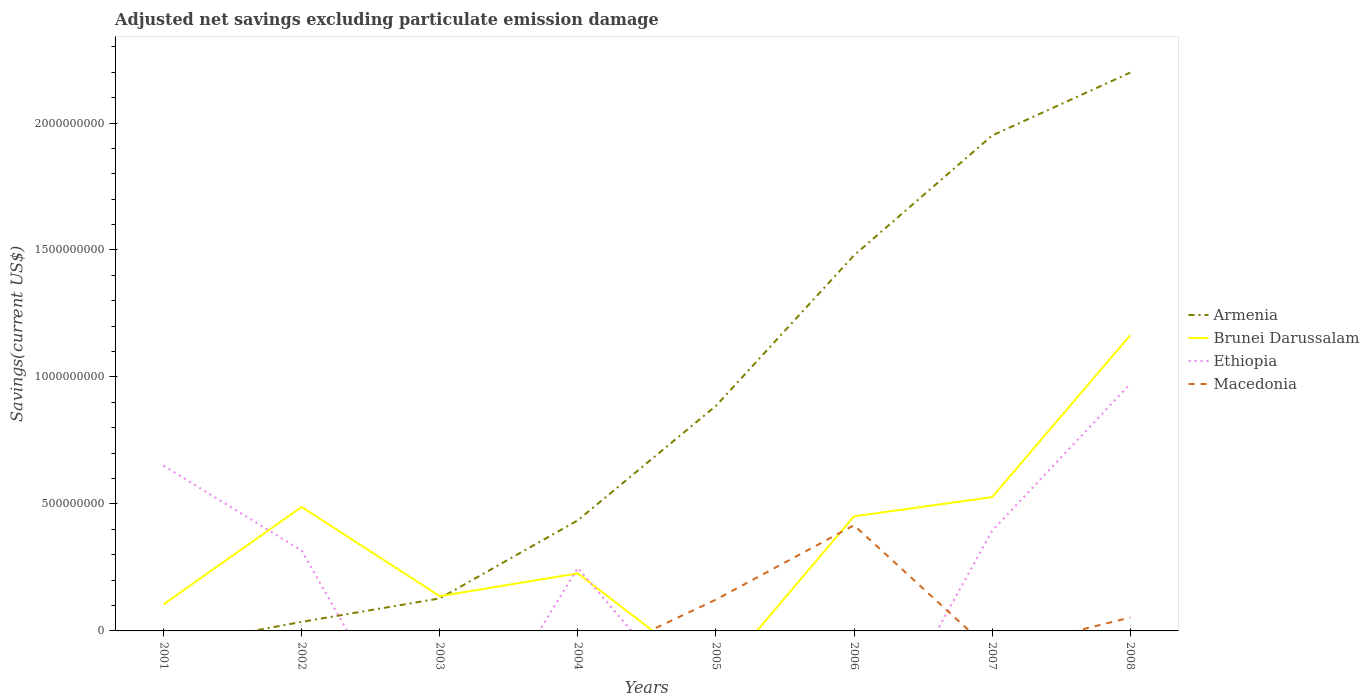Does the line corresponding to Ethiopia intersect with the line corresponding to Macedonia?
Provide a short and direct response. Yes. What is the total adjusted net savings in Brunei Darussalam in the graph?
Give a very brief answer. -3.00e+08. What is the difference between the highest and the second highest adjusted net savings in Brunei Darussalam?
Your answer should be compact. 1.16e+09. Is the adjusted net savings in Ethiopia strictly greater than the adjusted net savings in Macedonia over the years?
Your answer should be very brief. No. How many lines are there?
Offer a terse response. 4. Are the values on the major ticks of Y-axis written in scientific E-notation?
Keep it short and to the point. No. Does the graph contain grids?
Your response must be concise. No. Where does the legend appear in the graph?
Your response must be concise. Center right. How many legend labels are there?
Provide a short and direct response. 4. How are the legend labels stacked?
Ensure brevity in your answer.  Vertical. What is the title of the graph?
Your answer should be very brief. Adjusted net savings excluding particulate emission damage. What is the label or title of the X-axis?
Your answer should be very brief. Years. What is the label or title of the Y-axis?
Your answer should be very brief. Savings(current US$). What is the Savings(current US$) in Brunei Darussalam in 2001?
Offer a very short reply. 1.05e+08. What is the Savings(current US$) of Ethiopia in 2001?
Your response must be concise. 6.51e+08. What is the Savings(current US$) of Armenia in 2002?
Your answer should be compact. 3.57e+07. What is the Savings(current US$) of Brunei Darussalam in 2002?
Ensure brevity in your answer.  4.88e+08. What is the Savings(current US$) of Ethiopia in 2002?
Ensure brevity in your answer.  3.16e+08. What is the Savings(current US$) of Macedonia in 2002?
Provide a short and direct response. 0. What is the Savings(current US$) of Armenia in 2003?
Give a very brief answer. 1.28e+08. What is the Savings(current US$) of Brunei Darussalam in 2003?
Provide a short and direct response. 1.37e+08. What is the Savings(current US$) of Armenia in 2004?
Make the answer very short. 4.36e+08. What is the Savings(current US$) in Brunei Darussalam in 2004?
Offer a terse response. 2.27e+08. What is the Savings(current US$) in Ethiopia in 2004?
Offer a terse response. 2.48e+08. What is the Savings(current US$) in Armenia in 2005?
Provide a succinct answer. 8.86e+08. What is the Savings(current US$) in Ethiopia in 2005?
Make the answer very short. 0. What is the Savings(current US$) in Macedonia in 2005?
Provide a short and direct response. 1.23e+08. What is the Savings(current US$) of Armenia in 2006?
Your response must be concise. 1.48e+09. What is the Savings(current US$) in Brunei Darussalam in 2006?
Offer a terse response. 4.51e+08. What is the Savings(current US$) of Macedonia in 2006?
Make the answer very short. 4.16e+08. What is the Savings(current US$) of Armenia in 2007?
Offer a very short reply. 1.95e+09. What is the Savings(current US$) in Brunei Darussalam in 2007?
Give a very brief answer. 5.27e+08. What is the Savings(current US$) in Ethiopia in 2007?
Offer a very short reply. 3.94e+08. What is the Savings(current US$) in Macedonia in 2007?
Ensure brevity in your answer.  0. What is the Savings(current US$) in Armenia in 2008?
Your answer should be compact. 2.20e+09. What is the Savings(current US$) of Brunei Darussalam in 2008?
Provide a succinct answer. 1.16e+09. What is the Savings(current US$) of Ethiopia in 2008?
Make the answer very short. 9.73e+08. What is the Savings(current US$) in Macedonia in 2008?
Keep it short and to the point. 5.27e+07. Across all years, what is the maximum Savings(current US$) of Armenia?
Your answer should be very brief. 2.20e+09. Across all years, what is the maximum Savings(current US$) of Brunei Darussalam?
Your answer should be very brief. 1.16e+09. Across all years, what is the maximum Savings(current US$) in Ethiopia?
Offer a very short reply. 9.73e+08. Across all years, what is the maximum Savings(current US$) of Macedonia?
Offer a terse response. 4.16e+08. Across all years, what is the minimum Savings(current US$) of Armenia?
Keep it short and to the point. 0. Across all years, what is the minimum Savings(current US$) in Brunei Darussalam?
Ensure brevity in your answer.  0. Across all years, what is the minimum Savings(current US$) of Macedonia?
Provide a succinct answer. 0. What is the total Savings(current US$) in Armenia in the graph?
Your answer should be very brief. 7.11e+09. What is the total Savings(current US$) of Brunei Darussalam in the graph?
Ensure brevity in your answer.  3.10e+09. What is the total Savings(current US$) in Ethiopia in the graph?
Provide a succinct answer. 2.58e+09. What is the total Savings(current US$) of Macedonia in the graph?
Ensure brevity in your answer.  5.92e+08. What is the difference between the Savings(current US$) in Brunei Darussalam in 2001 and that in 2002?
Give a very brief answer. -3.84e+08. What is the difference between the Savings(current US$) of Ethiopia in 2001 and that in 2002?
Give a very brief answer. 3.34e+08. What is the difference between the Savings(current US$) of Brunei Darussalam in 2001 and that in 2003?
Provide a short and direct response. -3.24e+07. What is the difference between the Savings(current US$) of Brunei Darussalam in 2001 and that in 2004?
Your answer should be compact. -1.22e+08. What is the difference between the Savings(current US$) in Ethiopia in 2001 and that in 2004?
Your answer should be very brief. 4.03e+08. What is the difference between the Savings(current US$) in Brunei Darussalam in 2001 and that in 2006?
Your answer should be very brief. -3.47e+08. What is the difference between the Savings(current US$) in Brunei Darussalam in 2001 and that in 2007?
Ensure brevity in your answer.  -4.22e+08. What is the difference between the Savings(current US$) of Ethiopia in 2001 and that in 2007?
Offer a terse response. 2.56e+08. What is the difference between the Savings(current US$) of Brunei Darussalam in 2001 and that in 2008?
Your response must be concise. -1.06e+09. What is the difference between the Savings(current US$) in Ethiopia in 2001 and that in 2008?
Your response must be concise. -3.22e+08. What is the difference between the Savings(current US$) of Armenia in 2002 and that in 2003?
Make the answer very short. -9.23e+07. What is the difference between the Savings(current US$) of Brunei Darussalam in 2002 and that in 2003?
Make the answer very short. 3.51e+08. What is the difference between the Savings(current US$) of Armenia in 2002 and that in 2004?
Your answer should be very brief. -4.00e+08. What is the difference between the Savings(current US$) in Brunei Darussalam in 2002 and that in 2004?
Your answer should be very brief. 2.62e+08. What is the difference between the Savings(current US$) in Ethiopia in 2002 and that in 2004?
Your answer should be compact. 6.85e+07. What is the difference between the Savings(current US$) of Armenia in 2002 and that in 2005?
Your answer should be compact. -8.50e+08. What is the difference between the Savings(current US$) of Armenia in 2002 and that in 2006?
Offer a very short reply. -1.44e+09. What is the difference between the Savings(current US$) of Brunei Darussalam in 2002 and that in 2006?
Ensure brevity in your answer.  3.69e+07. What is the difference between the Savings(current US$) of Armenia in 2002 and that in 2007?
Your answer should be compact. -1.92e+09. What is the difference between the Savings(current US$) in Brunei Darussalam in 2002 and that in 2007?
Ensure brevity in your answer.  -3.85e+07. What is the difference between the Savings(current US$) of Ethiopia in 2002 and that in 2007?
Give a very brief answer. -7.81e+07. What is the difference between the Savings(current US$) in Armenia in 2002 and that in 2008?
Offer a very short reply. -2.16e+09. What is the difference between the Savings(current US$) in Brunei Darussalam in 2002 and that in 2008?
Your answer should be compact. -6.76e+08. What is the difference between the Savings(current US$) of Ethiopia in 2002 and that in 2008?
Make the answer very short. -6.56e+08. What is the difference between the Savings(current US$) of Armenia in 2003 and that in 2004?
Provide a short and direct response. -3.08e+08. What is the difference between the Savings(current US$) in Brunei Darussalam in 2003 and that in 2004?
Make the answer very short. -8.97e+07. What is the difference between the Savings(current US$) of Armenia in 2003 and that in 2005?
Make the answer very short. -7.58e+08. What is the difference between the Savings(current US$) in Armenia in 2003 and that in 2006?
Offer a very short reply. -1.35e+09. What is the difference between the Savings(current US$) of Brunei Darussalam in 2003 and that in 2006?
Your answer should be compact. -3.14e+08. What is the difference between the Savings(current US$) in Armenia in 2003 and that in 2007?
Provide a succinct answer. -1.82e+09. What is the difference between the Savings(current US$) of Brunei Darussalam in 2003 and that in 2007?
Your answer should be compact. -3.90e+08. What is the difference between the Savings(current US$) in Armenia in 2003 and that in 2008?
Give a very brief answer. -2.07e+09. What is the difference between the Savings(current US$) in Brunei Darussalam in 2003 and that in 2008?
Give a very brief answer. -1.03e+09. What is the difference between the Savings(current US$) of Armenia in 2004 and that in 2005?
Give a very brief answer. -4.50e+08. What is the difference between the Savings(current US$) in Armenia in 2004 and that in 2006?
Your answer should be compact. -1.04e+09. What is the difference between the Savings(current US$) in Brunei Darussalam in 2004 and that in 2006?
Offer a very short reply. -2.25e+08. What is the difference between the Savings(current US$) in Armenia in 2004 and that in 2007?
Offer a very short reply. -1.52e+09. What is the difference between the Savings(current US$) in Brunei Darussalam in 2004 and that in 2007?
Provide a short and direct response. -3.00e+08. What is the difference between the Savings(current US$) of Ethiopia in 2004 and that in 2007?
Keep it short and to the point. -1.47e+08. What is the difference between the Savings(current US$) in Armenia in 2004 and that in 2008?
Keep it short and to the point. -1.76e+09. What is the difference between the Savings(current US$) of Brunei Darussalam in 2004 and that in 2008?
Your answer should be compact. -9.38e+08. What is the difference between the Savings(current US$) of Ethiopia in 2004 and that in 2008?
Ensure brevity in your answer.  -7.25e+08. What is the difference between the Savings(current US$) in Armenia in 2005 and that in 2006?
Ensure brevity in your answer.  -5.93e+08. What is the difference between the Savings(current US$) in Macedonia in 2005 and that in 2006?
Your answer should be very brief. -2.93e+08. What is the difference between the Savings(current US$) of Armenia in 2005 and that in 2007?
Provide a short and direct response. -1.06e+09. What is the difference between the Savings(current US$) in Armenia in 2005 and that in 2008?
Your answer should be compact. -1.31e+09. What is the difference between the Savings(current US$) of Macedonia in 2005 and that in 2008?
Your answer should be compact. 7.05e+07. What is the difference between the Savings(current US$) in Armenia in 2006 and that in 2007?
Your answer should be very brief. -4.72e+08. What is the difference between the Savings(current US$) of Brunei Darussalam in 2006 and that in 2007?
Ensure brevity in your answer.  -7.55e+07. What is the difference between the Savings(current US$) in Armenia in 2006 and that in 2008?
Your answer should be very brief. -7.20e+08. What is the difference between the Savings(current US$) in Brunei Darussalam in 2006 and that in 2008?
Your response must be concise. -7.13e+08. What is the difference between the Savings(current US$) of Macedonia in 2006 and that in 2008?
Ensure brevity in your answer.  3.63e+08. What is the difference between the Savings(current US$) of Armenia in 2007 and that in 2008?
Your answer should be very brief. -2.48e+08. What is the difference between the Savings(current US$) in Brunei Darussalam in 2007 and that in 2008?
Make the answer very short. -6.38e+08. What is the difference between the Savings(current US$) in Ethiopia in 2007 and that in 2008?
Keep it short and to the point. -5.78e+08. What is the difference between the Savings(current US$) in Brunei Darussalam in 2001 and the Savings(current US$) in Ethiopia in 2002?
Give a very brief answer. -2.12e+08. What is the difference between the Savings(current US$) of Brunei Darussalam in 2001 and the Savings(current US$) of Ethiopia in 2004?
Give a very brief answer. -1.43e+08. What is the difference between the Savings(current US$) of Brunei Darussalam in 2001 and the Savings(current US$) of Macedonia in 2005?
Provide a succinct answer. -1.87e+07. What is the difference between the Savings(current US$) in Ethiopia in 2001 and the Savings(current US$) in Macedonia in 2005?
Provide a short and direct response. 5.27e+08. What is the difference between the Savings(current US$) in Brunei Darussalam in 2001 and the Savings(current US$) in Macedonia in 2006?
Make the answer very short. -3.12e+08. What is the difference between the Savings(current US$) of Ethiopia in 2001 and the Savings(current US$) of Macedonia in 2006?
Offer a very short reply. 2.35e+08. What is the difference between the Savings(current US$) of Brunei Darussalam in 2001 and the Savings(current US$) of Ethiopia in 2007?
Offer a terse response. -2.90e+08. What is the difference between the Savings(current US$) of Brunei Darussalam in 2001 and the Savings(current US$) of Ethiopia in 2008?
Your answer should be very brief. -8.68e+08. What is the difference between the Savings(current US$) of Brunei Darussalam in 2001 and the Savings(current US$) of Macedonia in 2008?
Ensure brevity in your answer.  5.18e+07. What is the difference between the Savings(current US$) of Ethiopia in 2001 and the Savings(current US$) of Macedonia in 2008?
Provide a succinct answer. 5.98e+08. What is the difference between the Savings(current US$) in Armenia in 2002 and the Savings(current US$) in Brunei Darussalam in 2003?
Your answer should be very brief. -1.01e+08. What is the difference between the Savings(current US$) of Armenia in 2002 and the Savings(current US$) of Brunei Darussalam in 2004?
Provide a short and direct response. -1.91e+08. What is the difference between the Savings(current US$) in Armenia in 2002 and the Savings(current US$) in Ethiopia in 2004?
Give a very brief answer. -2.12e+08. What is the difference between the Savings(current US$) of Brunei Darussalam in 2002 and the Savings(current US$) of Ethiopia in 2004?
Offer a very short reply. 2.40e+08. What is the difference between the Savings(current US$) in Armenia in 2002 and the Savings(current US$) in Macedonia in 2005?
Your answer should be compact. -8.76e+07. What is the difference between the Savings(current US$) in Brunei Darussalam in 2002 and the Savings(current US$) in Macedonia in 2005?
Offer a terse response. 3.65e+08. What is the difference between the Savings(current US$) of Ethiopia in 2002 and the Savings(current US$) of Macedonia in 2005?
Offer a terse response. 1.93e+08. What is the difference between the Savings(current US$) in Armenia in 2002 and the Savings(current US$) in Brunei Darussalam in 2006?
Your answer should be very brief. -4.16e+08. What is the difference between the Savings(current US$) of Armenia in 2002 and the Savings(current US$) of Macedonia in 2006?
Your answer should be very brief. -3.80e+08. What is the difference between the Savings(current US$) of Brunei Darussalam in 2002 and the Savings(current US$) of Macedonia in 2006?
Offer a terse response. 7.22e+07. What is the difference between the Savings(current US$) in Ethiopia in 2002 and the Savings(current US$) in Macedonia in 2006?
Provide a short and direct response. -9.97e+07. What is the difference between the Savings(current US$) of Armenia in 2002 and the Savings(current US$) of Brunei Darussalam in 2007?
Give a very brief answer. -4.91e+08. What is the difference between the Savings(current US$) of Armenia in 2002 and the Savings(current US$) of Ethiopia in 2007?
Provide a short and direct response. -3.59e+08. What is the difference between the Savings(current US$) in Brunei Darussalam in 2002 and the Savings(current US$) in Ethiopia in 2007?
Offer a terse response. 9.38e+07. What is the difference between the Savings(current US$) in Armenia in 2002 and the Savings(current US$) in Brunei Darussalam in 2008?
Ensure brevity in your answer.  -1.13e+09. What is the difference between the Savings(current US$) in Armenia in 2002 and the Savings(current US$) in Ethiopia in 2008?
Your answer should be very brief. -9.37e+08. What is the difference between the Savings(current US$) in Armenia in 2002 and the Savings(current US$) in Macedonia in 2008?
Give a very brief answer. -1.71e+07. What is the difference between the Savings(current US$) of Brunei Darussalam in 2002 and the Savings(current US$) of Ethiopia in 2008?
Provide a succinct answer. -4.84e+08. What is the difference between the Savings(current US$) in Brunei Darussalam in 2002 and the Savings(current US$) in Macedonia in 2008?
Provide a short and direct response. 4.36e+08. What is the difference between the Savings(current US$) of Ethiopia in 2002 and the Savings(current US$) of Macedonia in 2008?
Your answer should be very brief. 2.64e+08. What is the difference between the Savings(current US$) in Armenia in 2003 and the Savings(current US$) in Brunei Darussalam in 2004?
Keep it short and to the point. -9.87e+07. What is the difference between the Savings(current US$) of Armenia in 2003 and the Savings(current US$) of Ethiopia in 2004?
Offer a very short reply. -1.20e+08. What is the difference between the Savings(current US$) in Brunei Darussalam in 2003 and the Savings(current US$) in Ethiopia in 2004?
Your answer should be very brief. -1.11e+08. What is the difference between the Savings(current US$) in Armenia in 2003 and the Savings(current US$) in Macedonia in 2005?
Offer a very short reply. 4.75e+06. What is the difference between the Savings(current US$) in Brunei Darussalam in 2003 and the Savings(current US$) in Macedonia in 2005?
Make the answer very short. 1.37e+07. What is the difference between the Savings(current US$) in Armenia in 2003 and the Savings(current US$) in Brunei Darussalam in 2006?
Your answer should be very brief. -3.23e+08. What is the difference between the Savings(current US$) of Armenia in 2003 and the Savings(current US$) of Macedonia in 2006?
Give a very brief answer. -2.88e+08. What is the difference between the Savings(current US$) of Brunei Darussalam in 2003 and the Savings(current US$) of Macedonia in 2006?
Make the answer very short. -2.79e+08. What is the difference between the Savings(current US$) in Armenia in 2003 and the Savings(current US$) in Brunei Darussalam in 2007?
Make the answer very short. -3.99e+08. What is the difference between the Savings(current US$) in Armenia in 2003 and the Savings(current US$) in Ethiopia in 2007?
Your response must be concise. -2.67e+08. What is the difference between the Savings(current US$) of Brunei Darussalam in 2003 and the Savings(current US$) of Ethiopia in 2007?
Provide a short and direct response. -2.58e+08. What is the difference between the Savings(current US$) of Armenia in 2003 and the Savings(current US$) of Brunei Darussalam in 2008?
Provide a succinct answer. -1.04e+09. What is the difference between the Savings(current US$) in Armenia in 2003 and the Savings(current US$) in Ethiopia in 2008?
Your answer should be very brief. -8.45e+08. What is the difference between the Savings(current US$) of Armenia in 2003 and the Savings(current US$) of Macedonia in 2008?
Give a very brief answer. 7.52e+07. What is the difference between the Savings(current US$) in Brunei Darussalam in 2003 and the Savings(current US$) in Ethiopia in 2008?
Ensure brevity in your answer.  -8.36e+08. What is the difference between the Savings(current US$) in Brunei Darussalam in 2003 and the Savings(current US$) in Macedonia in 2008?
Make the answer very short. 8.42e+07. What is the difference between the Savings(current US$) in Armenia in 2004 and the Savings(current US$) in Macedonia in 2005?
Offer a very short reply. 3.12e+08. What is the difference between the Savings(current US$) in Brunei Darussalam in 2004 and the Savings(current US$) in Macedonia in 2005?
Offer a very short reply. 1.03e+08. What is the difference between the Savings(current US$) in Ethiopia in 2004 and the Savings(current US$) in Macedonia in 2005?
Provide a short and direct response. 1.25e+08. What is the difference between the Savings(current US$) in Armenia in 2004 and the Savings(current US$) in Brunei Darussalam in 2006?
Give a very brief answer. -1.58e+07. What is the difference between the Savings(current US$) in Armenia in 2004 and the Savings(current US$) in Macedonia in 2006?
Offer a terse response. 1.95e+07. What is the difference between the Savings(current US$) in Brunei Darussalam in 2004 and the Savings(current US$) in Macedonia in 2006?
Keep it short and to the point. -1.89e+08. What is the difference between the Savings(current US$) in Ethiopia in 2004 and the Savings(current US$) in Macedonia in 2006?
Provide a short and direct response. -1.68e+08. What is the difference between the Savings(current US$) in Armenia in 2004 and the Savings(current US$) in Brunei Darussalam in 2007?
Give a very brief answer. -9.12e+07. What is the difference between the Savings(current US$) of Armenia in 2004 and the Savings(current US$) of Ethiopia in 2007?
Keep it short and to the point. 4.11e+07. What is the difference between the Savings(current US$) in Brunei Darussalam in 2004 and the Savings(current US$) in Ethiopia in 2007?
Offer a terse response. -1.68e+08. What is the difference between the Savings(current US$) of Armenia in 2004 and the Savings(current US$) of Brunei Darussalam in 2008?
Provide a succinct answer. -7.29e+08. What is the difference between the Savings(current US$) of Armenia in 2004 and the Savings(current US$) of Ethiopia in 2008?
Your response must be concise. -5.37e+08. What is the difference between the Savings(current US$) in Armenia in 2004 and the Savings(current US$) in Macedonia in 2008?
Offer a very short reply. 3.83e+08. What is the difference between the Savings(current US$) in Brunei Darussalam in 2004 and the Savings(current US$) in Ethiopia in 2008?
Your response must be concise. -7.46e+08. What is the difference between the Savings(current US$) in Brunei Darussalam in 2004 and the Savings(current US$) in Macedonia in 2008?
Offer a very short reply. 1.74e+08. What is the difference between the Savings(current US$) of Ethiopia in 2004 and the Savings(current US$) of Macedonia in 2008?
Your response must be concise. 1.95e+08. What is the difference between the Savings(current US$) in Armenia in 2005 and the Savings(current US$) in Brunei Darussalam in 2006?
Your response must be concise. 4.35e+08. What is the difference between the Savings(current US$) of Armenia in 2005 and the Savings(current US$) of Macedonia in 2006?
Offer a terse response. 4.70e+08. What is the difference between the Savings(current US$) in Armenia in 2005 and the Savings(current US$) in Brunei Darussalam in 2007?
Your response must be concise. 3.59e+08. What is the difference between the Savings(current US$) of Armenia in 2005 and the Savings(current US$) of Ethiopia in 2007?
Your answer should be compact. 4.92e+08. What is the difference between the Savings(current US$) in Armenia in 2005 and the Savings(current US$) in Brunei Darussalam in 2008?
Your answer should be compact. -2.78e+08. What is the difference between the Savings(current US$) in Armenia in 2005 and the Savings(current US$) in Ethiopia in 2008?
Keep it short and to the point. -8.66e+07. What is the difference between the Savings(current US$) of Armenia in 2005 and the Savings(current US$) of Macedonia in 2008?
Your answer should be compact. 8.33e+08. What is the difference between the Savings(current US$) in Armenia in 2006 and the Savings(current US$) in Brunei Darussalam in 2007?
Your response must be concise. 9.52e+08. What is the difference between the Savings(current US$) in Armenia in 2006 and the Savings(current US$) in Ethiopia in 2007?
Provide a succinct answer. 1.08e+09. What is the difference between the Savings(current US$) in Brunei Darussalam in 2006 and the Savings(current US$) in Ethiopia in 2007?
Your answer should be compact. 5.69e+07. What is the difference between the Savings(current US$) of Armenia in 2006 and the Savings(current US$) of Brunei Darussalam in 2008?
Keep it short and to the point. 3.15e+08. What is the difference between the Savings(current US$) in Armenia in 2006 and the Savings(current US$) in Ethiopia in 2008?
Offer a terse response. 5.06e+08. What is the difference between the Savings(current US$) of Armenia in 2006 and the Savings(current US$) of Macedonia in 2008?
Your response must be concise. 1.43e+09. What is the difference between the Savings(current US$) in Brunei Darussalam in 2006 and the Savings(current US$) in Ethiopia in 2008?
Your answer should be very brief. -5.21e+08. What is the difference between the Savings(current US$) of Brunei Darussalam in 2006 and the Savings(current US$) of Macedonia in 2008?
Ensure brevity in your answer.  3.99e+08. What is the difference between the Savings(current US$) in Armenia in 2007 and the Savings(current US$) in Brunei Darussalam in 2008?
Your answer should be compact. 7.86e+08. What is the difference between the Savings(current US$) in Armenia in 2007 and the Savings(current US$) in Ethiopia in 2008?
Your response must be concise. 9.78e+08. What is the difference between the Savings(current US$) of Armenia in 2007 and the Savings(current US$) of Macedonia in 2008?
Provide a succinct answer. 1.90e+09. What is the difference between the Savings(current US$) in Brunei Darussalam in 2007 and the Savings(current US$) in Ethiopia in 2008?
Make the answer very short. -4.46e+08. What is the difference between the Savings(current US$) of Brunei Darussalam in 2007 and the Savings(current US$) of Macedonia in 2008?
Provide a short and direct response. 4.74e+08. What is the difference between the Savings(current US$) of Ethiopia in 2007 and the Savings(current US$) of Macedonia in 2008?
Your answer should be very brief. 3.42e+08. What is the average Savings(current US$) of Armenia per year?
Ensure brevity in your answer.  8.89e+08. What is the average Savings(current US$) in Brunei Darussalam per year?
Ensure brevity in your answer.  3.87e+08. What is the average Savings(current US$) of Ethiopia per year?
Make the answer very short. 3.23e+08. What is the average Savings(current US$) of Macedonia per year?
Offer a terse response. 7.40e+07. In the year 2001, what is the difference between the Savings(current US$) in Brunei Darussalam and Savings(current US$) in Ethiopia?
Make the answer very short. -5.46e+08. In the year 2002, what is the difference between the Savings(current US$) in Armenia and Savings(current US$) in Brunei Darussalam?
Your response must be concise. -4.53e+08. In the year 2002, what is the difference between the Savings(current US$) of Armenia and Savings(current US$) of Ethiopia?
Provide a short and direct response. -2.81e+08. In the year 2002, what is the difference between the Savings(current US$) of Brunei Darussalam and Savings(current US$) of Ethiopia?
Provide a succinct answer. 1.72e+08. In the year 2003, what is the difference between the Savings(current US$) of Armenia and Savings(current US$) of Brunei Darussalam?
Offer a terse response. -8.96e+06. In the year 2004, what is the difference between the Savings(current US$) in Armenia and Savings(current US$) in Brunei Darussalam?
Make the answer very short. 2.09e+08. In the year 2004, what is the difference between the Savings(current US$) of Armenia and Savings(current US$) of Ethiopia?
Provide a succinct answer. 1.88e+08. In the year 2004, what is the difference between the Savings(current US$) of Brunei Darussalam and Savings(current US$) of Ethiopia?
Your answer should be very brief. -2.12e+07. In the year 2005, what is the difference between the Savings(current US$) of Armenia and Savings(current US$) of Macedonia?
Make the answer very short. 7.63e+08. In the year 2006, what is the difference between the Savings(current US$) of Armenia and Savings(current US$) of Brunei Darussalam?
Your answer should be compact. 1.03e+09. In the year 2006, what is the difference between the Savings(current US$) of Armenia and Savings(current US$) of Macedonia?
Ensure brevity in your answer.  1.06e+09. In the year 2006, what is the difference between the Savings(current US$) in Brunei Darussalam and Savings(current US$) in Macedonia?
Give a very brief answer. 3.53e+07. In the year 2007, what is the difference between the Savings(current US$) of Armenia and Savings(current US$) of Brunei Darussalam?
Your answer should be very brief. 1.42e+09. In the year 2007, what is the difference between the Savings(current US$) in Armenia and Savings(current US$) in Ethiopia?
Give a very brief answer. 1.56e+09. In the year 2007, what is the difference between the Savings(current US$) of Brunei Darussalam and Savings(current US$) of Ethiopia?
Keep it short and to the point. 1.32e+08. In the year 2008, what is the difference between the Savings(current US$) of Armenia and Savings(current US$) of Brunei Darussalam?
Ensure brevity in your answer.  1.03e+09. In the year 2008, what is the difference between the Savings(current US$) of Armenia and Savings(current US$) of Ethiopia?
Ensure brevity in your answer.  1.23e+09. In the year 2008, what is the difference between the Savings(current US$) in Armenia and Savings(current US$) in Macedonia?
Ensure brevity in your answer.  2.15e+09. In the year 2008, what is the difference between the Savings(current US$) in Brunei Darussalam and Savings(current US$) in Ethiopia?
Your answer should be compact. 1.92e+08. In the year 2008, what is the difference between the Savings(current US$) of Brunei Darussalam and Savings(current US$) of Macedonia?
Provide a succinct answer. 1.11e+09. In the year 2008, what is the difference between the Savings(current US$) in Ethiopia and Savings(current US$) in Macedonia?
Offer a very short reply. 9.20e+08. What is the ratio of the Savings(current US$) in Brunei Darussalam in 2001 to that in 2002?
Offer a very short reply. 0.21. What is the ratio of the Savings(current US$) of Ethiopia in 2001 to that in 2002?
Your answer should be very brief. 2.06. What is the ratio of the Savings(current US$) of Brunei Darussalam in 2001 to that in 2003?
Provide a short and direct response. 0.76. What is the ratio of the Savings(current US$) of Brunei Darussalam in 2001 to that in 2004?
Provide a short and direct response. 0.46. What is the ratio of the Savings(current US$) in Ethiopia in 2001 to that in 2004?
Offer a very short reply. 2.62. What is the ratio of the Savings(current US$) of Brunei Darussalam in 2001 to that in 2006?
Give a very brief answer. 0.23. What is the ratio of the Savings(current US$) in Brunei Darussalam in 2001 to that in 2007?
Offer a very short reply. 0.2. What is the ratio of the Savings(current US$) of Ethiopia in 2001 to that in 2007?
Provide a succinct answer. 1.65. What is the ratio of the Savings(current US$) of Brunei Darussalam in 2001 to that in 2008?
Provide a short and direct response. 0.09. What is the ratio of the Savings(current US$) in Ethiopia in 2001 to that in 2008?
Your answer should be compact. 0.67. What is the ratio of the Savings(current US$) in Armenia in 2002 to that in 2003?
Offer a very short reply. 0.28. What is the ratio of the Savings(current US$) in Brunei Darussalam in 2002 to that in 2003?
Give a very brief answer. 3.57. What is the ratio of the Savings(current US$) of Armenia in 2002 to that in 2004?
Your answer should be compact. 0.08. What is the ratio of the Savings(current US$) of Brunei Darussalam in 2002 to that in 2004?
Make the answer very short. 2.15. What is the ratio of the Savings(current US$) of Ethiopia in 2002 to that in 2004?
Your answer should be very brief. 1.28. What is the ratio of the Savings(current US$) of Armenia in 2002 to that in 2005?
Keep it short and to the point. 0.04. What is the ratio of the Savings(current US$) of Armenia in 2002 to that in 2006?
Your response must be concise. 0.02. What is the ratio of the Savings(current US$) in Brunei Darussalam in 2002 to that in 2006?
Offer a very short reply. 1.08. What is the ratio of the Savings(current US$) of Armenia in 2002 to that in 2007?
Offer a terse response. 0.02. What is the ratio of the Savings(current US$) of Brunei Darussalam in 2002 to that in 2007?
Ensure brevity in your answer.  0.93. What is the ratio of the Savings(current US$) of Ethiopia in 2002 to that in 2007?
Your answer should be compact. 0.8. What is the ratio of the Savings(current US$) of Armenia in 2002 to that in 2008?
Ensure brevity in your answer.  0.02. What is the ratio of the Savings(current US$) of Brunei Darussalam in 2002 to that in 2008?
Your answer should be compact. 0.42. What is the ratio of the Savings(current US$) of Ethiopia in 2002 to that in 2008?
Ensure brevity in your answer.  0.33. What is the ratio of the Savings(current US$) of Armenia in 2003 to that in 2004?
Your answer should be very brief. 0.29. What is the ratio of the Savings(current US$) in Brunei Darussalam in 2003 to that in 2004?
Offer a very short reply. 0.6. What is the ratio of the Savings(current US$) of Armenia in 2003 to that in 2005?
Offer a very short reply. 0.14. What is the ratio of the Savings(current US$) in Armenia in 2003 to that in 2006?
Ensure brevity in your answer.  0.09. What is the ratio of the Savings(current US$) in Brunei Darussalam in 2003 to that in 2006?
Offer a very short reply. 0.3. What is the ratio of the Savings(current US$) in Armenia in 2003 to that in 2007?
Your answer should be compact. 0.07. What is the ratio of the Savings(current US$) in Brunei Darussalam in 2003 to that in 2007?
Provide a short and direct response. 0.26. What is the ratio of the Savings(current US$) of Armenia in 2003 to that in 2008?
Offer a very short reply. 0.06. What is the ratio of the Savings(current US$) of Brunei Darussalam in 2003 to that in 2008?
Your response must be concise. 0.12. What is the ratio of the Savings(current US$) in Armenia in 2004 to that in 2005?
Offer a terse response. 0.49. What is the ratio of the Savings(current US$) of Armenia in 2004 to that in 2006?
Ensure brevity in your answer.  0.29. What is the ratio of the Savings(current US$) of Brunei Darussalam in 2004 to that in 2006?
Your response must be concise. 0.5. What is the ratio of the Savings(current US$) in Armenia in 2004 to that in 2007?
Offer a terse response. 0.22. What is the ratio of the Savings(current US$) of Brunei Darussalam in 2004 to that in 2007?
Give a very brief answer. 0.43. What is the ratio of the Savings(current US$) of Ethiopia in 2004 to that in 2007?
Ensure brevity in your answer.  0.63. What is the ratio of the Savings(current US$) in Armenia in 2004 to that in 2008?
Give a very brief answer. 0.2. What is the ratio of the Savings(current US$) of Brunei Darussalam in 2004 to that in 2008?
Your answer should be very brief. 0.19. What is the ratio of the Savings(current US$) of Ethiopia in 2004 to that in 2008?
Your answer should be very brief. 0.25. What is the ratio of the Savings(current US$) in Armenia in 2005 to that in 2006?
Give a very brief answer. 0.6. What is the ratio of the Savings(current US$) of Macedonia in 2005 to that in 2006?
Provide a succinct answer. 0.3. What is the ratio of the Savings(current US$) of Armenia in 2005 to that in 2007?
Provide a short and direct response. 0.45. What is the ratio of the Savings(current US$) of Armenia in 2005 to that in 2008?
Make the answer very short. 0.4. What is the ratio of the Savings(current US$) of Macedonia in 2005 to that in 2008?
Keep it short and to the point. 2.34. What is the ratio of the Savings(current US$) of Armenia in 2006 to that in 2007?
Keep it short and to the point. 0.76. What is the ratio of the Savings(current US$) in Brunei Darussalam in 2006 to that in 2007?
Offer a terse response. 0.86. What is the ratio of the Savings(current US$) of Armenia in 2006 to that in 2008?
Make the answer very short. 0.67. What is the ratio of the Savings(current US$) of Brunei Darussalam in 2006 to that in 2008?
Give a very brief answer. 0.39. What is the ratio of the Savings(current US$) in Macedonia in 2006 to that in 2008?
Offer a very short reply. 7.89. What is the ratio of the Savings(current US$) in Armenia in 2007 to that in 2008?
Provide a succinct answer. 0.89. What is the ratio of the Savings(current US$) in Brunei Darussalam in 2007 to that in 2008?
Offer a very short reply. 0.45. What is the ratio of the Savings(current US$) of Ethiopia in 2007 to that in 2008?
Your response must be concise. 0.41. What is the difference between the highest and the second highest Savings(current US$) of Armenia?
Your answer should be very brief. 2.48e+08. What is the difference between the highest and the second highest Savings(current US$) of Brunei Darussalam?
Keep it short and to the point. 6.38e+08. What is the difference between the highest and the second highest Savings(current US$) of Ethiopia?
Ensure brevity in your answer.  3.22e+08. What is the difference between the highest and the second highest Savings(current US$) in Macedonia?
Your answer should be very brief. 2.93e+08. What is the difference between the highest and the lowest Savings(current US$) in Armenia?
Make the answer very short. 2.20e+09. What is the difference between the highest and the lowest Savings(current US$) in Brunei Darussalam?
Your response must be concise. 1.16e+09. What is the difference between the highest and the lowest Savings(current US$) in Ethiopia?
Keep it short and to the point. 9.73e+08. What is the difference between the highest and the lowest Savings(current US$) in Macedonia?
Offer a terse response. 4.16e+08. 